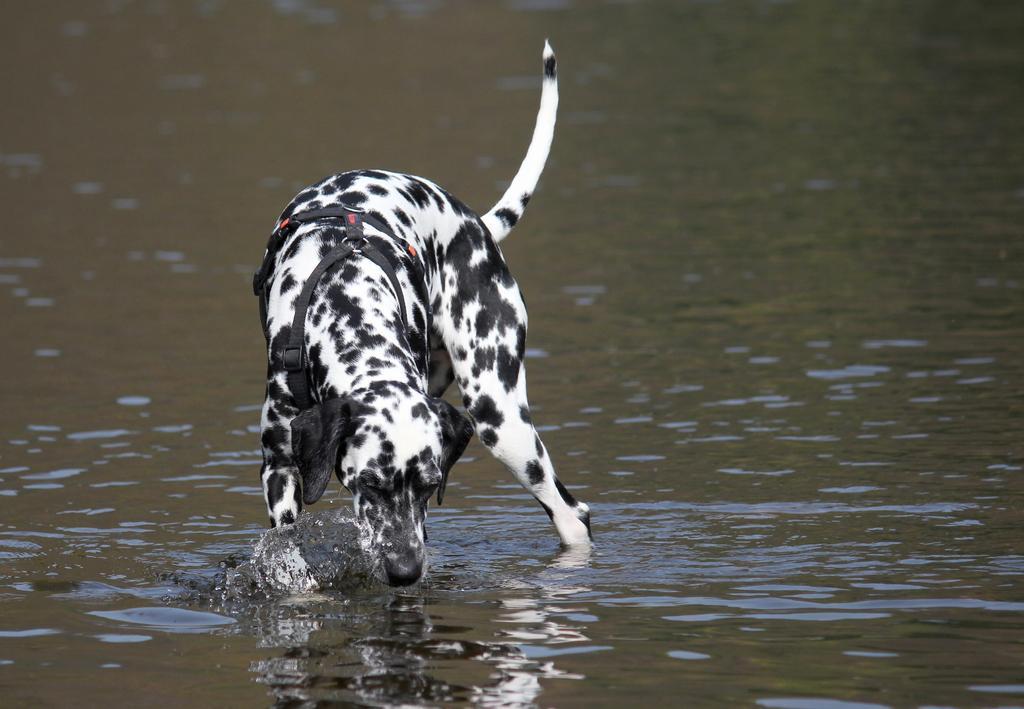Describe this image in one or two sentences. In the center of the image, we can see a dog and at the bottom, there is water. 